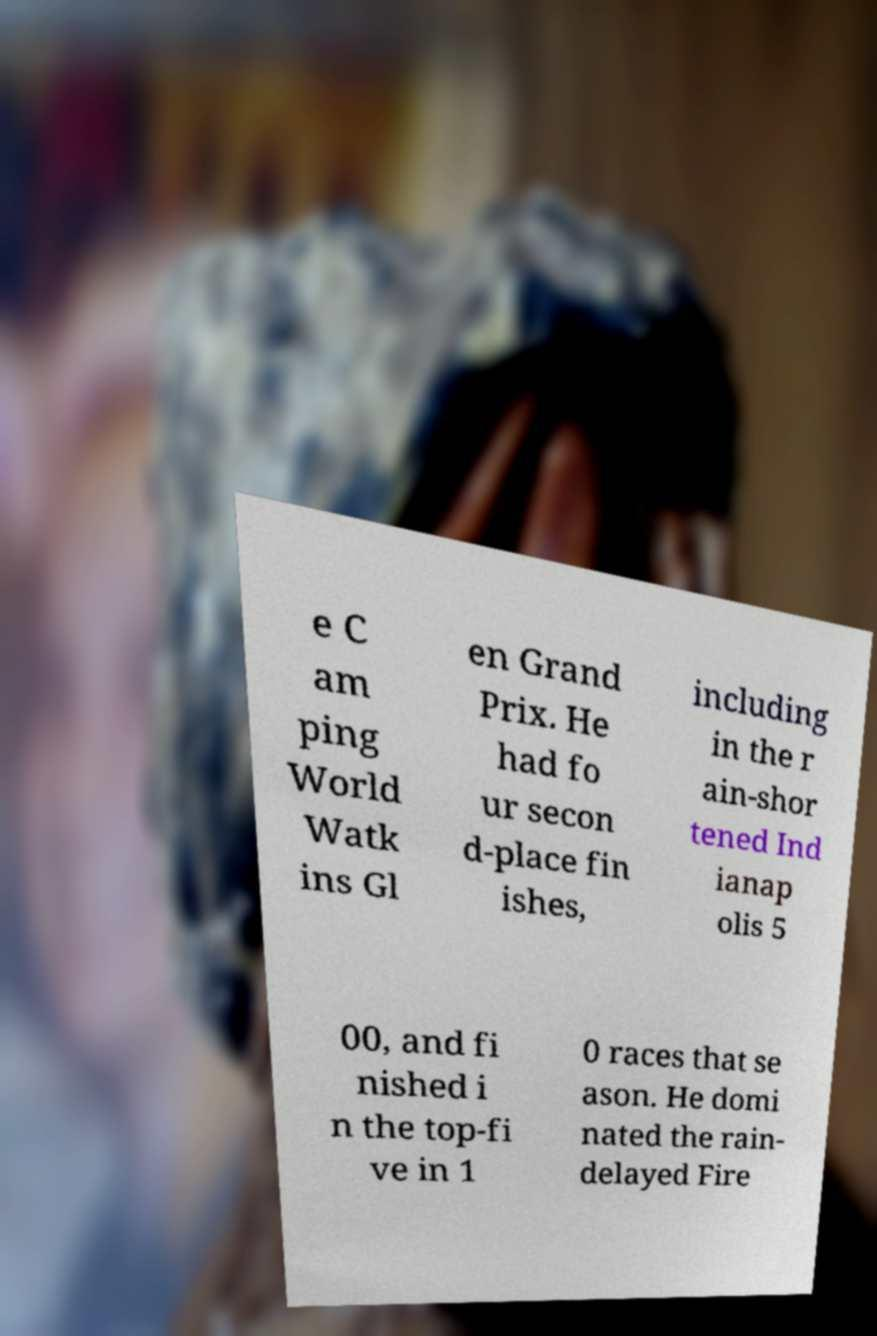Can you accurately transcribe the text from the provided image for me? e C am ping World Watk ins Gl en Grand Prix. He had fo ur secon d-place fin ishes, including in the r ain-shor tened Ind ianap olis 5 00, and fi nished i n the top-fi ve in 1 0 races that se ason. He domi nated the rain- delayed Fire 